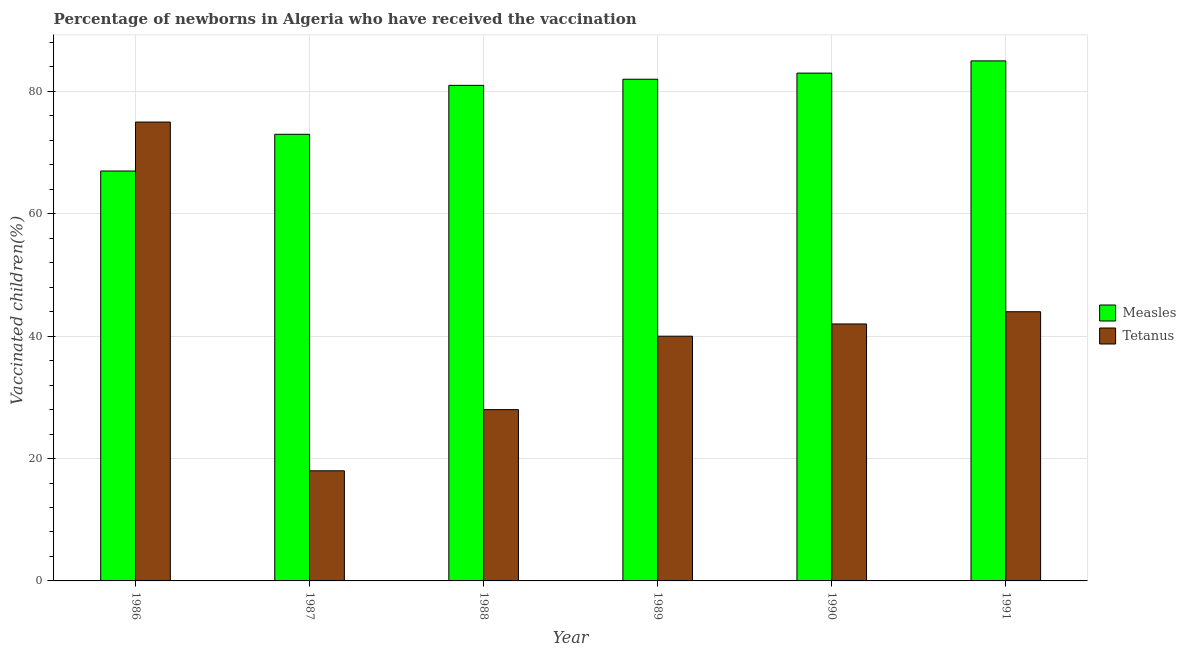How many different coloured bars are there?
Ensure brevity in your answer.  2. How many bars are there on the 4th tick from the left?
Your answer should be very brief. 2. What is the percentage of newborns who received vaccination for measles in 1991?
Give a very brief answer. 85. Across all years, what is the maximum percentage of newborns who received vaccination for tetanus?
Provide a succinct answer. 75. Across all years, what is the minimum percentage of newborns who received vaccination for measles?
Provide a short and direct response. 67. In which year was the percentage of newborns who received vaccination for measles maximum?
Give a very brief answer. 1991. In which year was the percentage of newborns who received vaccination for tetanus minimum?
Provide a short and direct response. 1987. What is the total percentage of newborns who received vaccination for measles in the graph?
Offer a terse response. 471. What is the difference between the percentage of newborns who received vaccination for measles in 1986 and that in 1990?
Ensure brevity in your answer.  -16. What is the difference between the percentage of newborns who received vaccination for measles in 1989 and the percentage of newborns who received vaccination for tetanus in 1986?
Give a very brief answer. 15. What is the average percentage of newborns who received vaccination for tetanus per year?
Your response must be concise. 41.17. In the year 1991, what is the difference between the percentage of newborns who received vaccination for measles and percentage of newborns who received vaccination for tetanus?
Provide a succinct answer. 0. What is the difference between the highest and the second highest percentage of newborns who received vaccination for tetanus?
Your response must be concise. 31. What is the difference between the highest and the lowest percentage of newborns who received vaccination for tetanus?
Your response must be concise. 57. In how many years, is the percentage of newborns who received vaccination for tetanus greater than the average percentage of newborns who received vaccination for tetanus taken over all years?
Provide a short and direct response. 3. Is the sum of the percentage of newborns who received vaccination for tetanus in 1990 and 1991 greater than the maximum percentage of newborns who received vaccination for measles across all years?
Provide a succinct answer. Yes. What does the 2nd bar from the left in 1986 represents?
Your response must be concise. Tetanus. What does the 2nd bar from the right in 1989 represents?
Your answer should be compact. Measles. Are all the bars in the graph horizontal?
Make the answer very short. No. How many years are there in the graph?
Give a very brief answer. 6. Does the graph contain any zero values?
Provide a short and direct response. No. Does the graph contain grids?
Your answer should be very brief. Yes. How many legend labels are there?
Offer a very short reply. 2. How are the legend labels stacked?
Offer a very short reply. Vertical. What is the title of the graph?
Provide a short and direct response. Percentage of newborns in Algeria who have received the vaccination. Does "Commercial service exports" appear as one of the legend labels in the graph?
Offer a very short reply. No. What is the label or title of the Y-axis?
Provide a short and direct response. Vaccinated children(%)
. What is the Vaccinated children(%)
 of Tetanus in 1986?
Your response must be concise. 75. What is the Vaccinated children(%)
 of Tetanus in 1987?
Keep it short and to the point. 18. What is the Vaccinated children(%)
 in Measles in 1988?
Your answer should be compact. 81. What is the Vaccinated children(%)
 of Tetanus in 1988?
Provide a succinct answer. 28. What is the Vaccinated children(%)
 in Tetanus in 1989?
Offer a very short reply. 40. What is the Vaccinated children(%)
 in Measles in 1990?
Your response must be concise. 83. What is the Vaccinated children(%)
 in Tetanus in 1990?
Your answer should be compact. 42. What is the Vaccinated children(%)
 in Measles in 1991?
Your answer should be compact. 85. What is the Vaccinated children(%)
 of Tetanus in 1991?
Your answer should be very brief. 44. Across all years, what is the maximum Vaccinated children(%)
 in Measles?
Provide a succinct answer. 85. What is the total Vaccinated children(%)
 in Measles in the graph?
Ensure brevity in your answer.  471. What is the total Vaccinated children(%)
 in Tetanus in the graph?
Ensure brevity in your answer.  247. What is the difference between the Vaccinated children(%)
 in Measles in 1986 and that in 1987?
Your answer should be compact. -6. What is the difference between the Vaccinated children(%)
 of Measles in 1986 and that in 1988?
Keep it short and to the point. -14. What is the difference between the Vaccinated children(%)
 of Measles in 1986 and that in 1989?
Make the answer very short. -15. What is the difference between the Vaccinated children(%)
 of Tetanus in 1986 and that in 1990?
Your answer should be compact. 33. What is the difference between the Vaccinated children(%)
 in Measles in 1986 and that in 1991?
Ensure brevity in your answer.  -18. What is the difference between the Vaccinated children(%)
 in Tetanus in 1986 and that in 1991?
Keep it short and to the point. 31. What is the difference between the Vaccinated children(%)
 in Tetanus in 1987 and that in 1988?
Make the answer very short. -10. What is the difference between the Vaccinated children(%)
 in Measles in 1987 and that in 1989?
Provide a short and direct response. -9. What is the difference between the Vaccinated children(%)
 of Tetanus in 1987 and that in 1989?
Your answer should be compact. -22. What is the difference between the Vaccinated children(%)
 of Measles in 1987 and that in 1990?
Provide a succinct answer. -10. What is the difference between the Vaccinated children(%)
 in Measles in 1987 and that in 1991?
Keep it short and to the point. -12. What is the difference between the Vaccinated children(%)
 in Measles in 1988 and that in 1989?
Offer a terse response. -1. What is the difference between the Vaccinated children(%)
 in Measles in 1988 and that in 1990?
Offer a very short reply. -2. What is the difference between the Vaccinated children(%)
 in Tetanus in 1988 and that in 1990?
Offer a very short reply. -14. What is the difference between the Vaccinated children(%)
 of Tetanus in 1988 and that in 1991?
Your answer should be very brief. -16. What is the difference between the Vaccinated children(%)
 in Tetanus in 1989 and that in 1990?
Your answer should be very brief. -2. What is the difference between the Vaccinated children(%)
 in Tetanus in 1989 and that in 1991?
Your response must be concise. -4. What is the difference between the Vaccinated children(%)
 of Measles in 1990 and that in 1991?
Make the answer very short. -2. What is the difference between the Vaccinated children(%)
 in Tetanus in 1990 and that in 1991?
Offer a very short reply. -2. What is the difference between the Vaccinated children(%)
 of Measles in 1986 and the Vaccinated children(%)
 of Tetanus in 1988?
Your answer should be compact. 39. What is the difference between the Vaccinated children(%)
 of Measles in 1986 and the Vaccinated children(%)
 of Tetanus in 1990?
Provide a succinct answer. 25. What is the difference between the Vaccinated children(%)
 in Measles in 1988 and the Vaccinated children(%)
 in Tetanus in 1990?
Offer a very short reply. 39. What is the difference between the Vaccinated children(%)
 in Measles in 1989 and the Vaccinated children(%)
 in Tetanus in 1990?
Offer a terse response. 40. What is the difference between the Vaccinated children(%)
 of Measles in 1989 and the Vaccinated children(%)
 of Tetanus in 1991?
Your response must be concise. 38. What is the average Vaccinated children(%)
 of Measles per year?
Keep it short and to the point. 78.5. What is the average Vaccinated children(%)
 of Tetanus per year?
Ensure brevity in your answer.  41.17. In the year 1988, what is the difference between the Vaccinated children(%)
 in Measles and Vaccinated children(%)
 in Tetanus?
Make the answer very short. 53. In the year 1991, what is the difference between the Vaccinated children(%)
 in Measles and Vaccinated children(%)
 in Tetanus?
Offer a terse response. 41. What is the ratio of the Vaccinated children(%)
 of Measles in 1986 to that in 1987?
Keep it short and to the point. 0.92. What is the ratio of the Vaccinated children(%)
 of Tetanus in 1986 to that in 1987?
Ensure brevity in your answer.  4.17. What is the ratio of the Vaccinated children(%)
 in Measles in 1986 to that in 1988?
Make the answer very short. 0.83. What is the ratio of the Vaccinated children(%)
 of Tetanus in 1986 to that in 1988?
Give a very brief answer. 2.68. What is the ratio of the Vaccinated children(%)
 of Measles in 1986 to that in 1989?
Your answer should be very brief. 0.82. What is the ratio of the Vaccinated children(%)
 of Tetanus in 1986 to that in 1989?
Your answer should be compact. 1.88. What is the ratio of the Vaccinated children(%)
 of Measles in 1986 to that in 1990?
Provide a succinct answer. 0.81. What is the ratio of the Vaccinated children(%)
 of Tetanus in 1986 to that in 1990?
Offer a terse response. 1.79. What is the ratio of the Vaccinated children(%)
 of Measles in 1986 to that in 1991?
Keep it short and to the point. 0.79. What is the ratio of the Vaccinated children(%)
 in Tetanus in 1986 to that in 1991?
Offer a very short reply. 1.7. What is the ratio of the Vaccinated children(%)
 in Measles in 1987 to that in 1988?
Offer a very short reply. 0.9. What is the ratio of the Vaccinated children(%)
 in Tetanus in 1987 to that in 1988?
Keep it short and to the point. 0.64. What is the ratio of the Vaccinated children(%)
 of Measles in 1987 to that in 1989?
Make the answer very short. 0.89. What is the ratio of the Vaccinated children(%)
 of Tetanus in 1987 to that in 1989?
Your response must be concise. 0.45. What is the ratio of the Vaccinated children(%)
 of Measles in 1987 to that in 1990?
Your response must be concise. 0.88. What is the ratio of the Vaccinated children(%)
 in Tetanus in 1987 to that in 1990?
Provide a short and direct response. 0.43. What is the ratio of the Vaccinated children(%)
 in Measles in 1987 to that in 1991?
Offer a terse response. 0.86. What is the ratio of the Vaccinated children(%)
 of Tetanus in 1987 to that in 1991?
Your answer should be very brief. 0.41. What is the ratio of the Vaccinated children(%)
 of Measles in 1988 to that in 1989?
Your answer should be compact. 0.99. What is the ratio of the Vaccinated children(%)
 of Tetanus in 1988 to that in 1989?
Your answer should be very brief. 0.7. What is the ratio of the Vaccinated children(%)
 in Measles in 1988 to that in 1990?
Your answer should be very brief. 0.98. What is the ratio of the Vaccinated children(%)
 in Measles in 1988 to that in 1991?
Your answer should be very brief. 0.95. What is the ratio of the Vaccinated children(%)
 in Tetanus in 1988 to that in 1991?
Provide a succinct answer. 0.64. What is the ratio of the Vaccinated children(%)
 in Measles in 1989 to that in 1991?
Offer a terse response. 0.96. What is the ratio of the Vaccinated children(%)
 in Measles in 1990 to that in 1991?
Your response must be concise. 0.98. What is the ratio of the Vaccinated children(%)
 in Tetanus in 1990 to that in 1991?
Your answer should be very brief. 0.95. What is the difference between the highest and the second highest Vaccinated children(%)
 in Tetanus?
Provide a short and direct response. 31. What is the difference between the highest and the lowest Vaccinated children(%)
 in Measles?
Your response must be concise. 18. What is the difference between the highest and the lowest Vaccinated children(%)
 in Tetanus?
Make the answer very short. 57. 